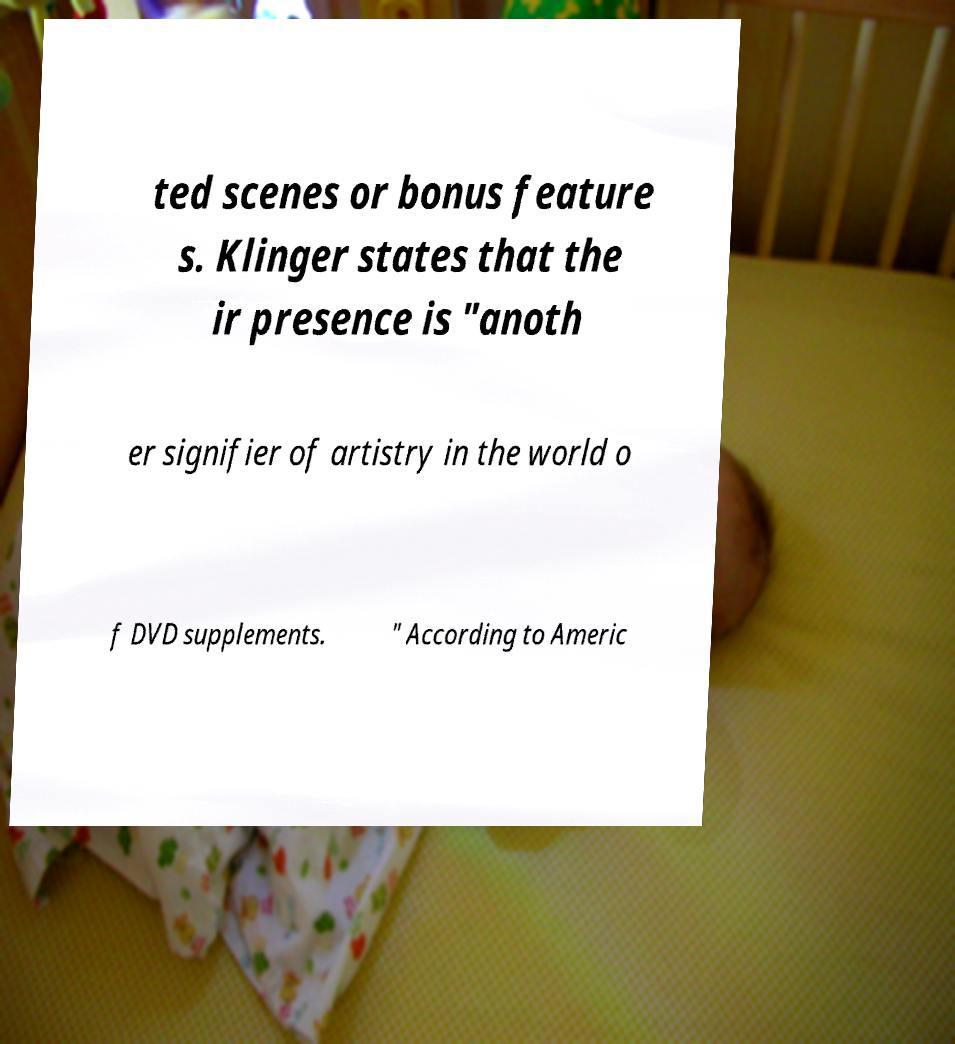What messages or text are displayed in this image? I need them in a readable, typed format. ted scenes or bonus feature s. Klinger states that the ir presence is "anoth er signifier of artistry in the world o f DVD supplements. " According to Americ 